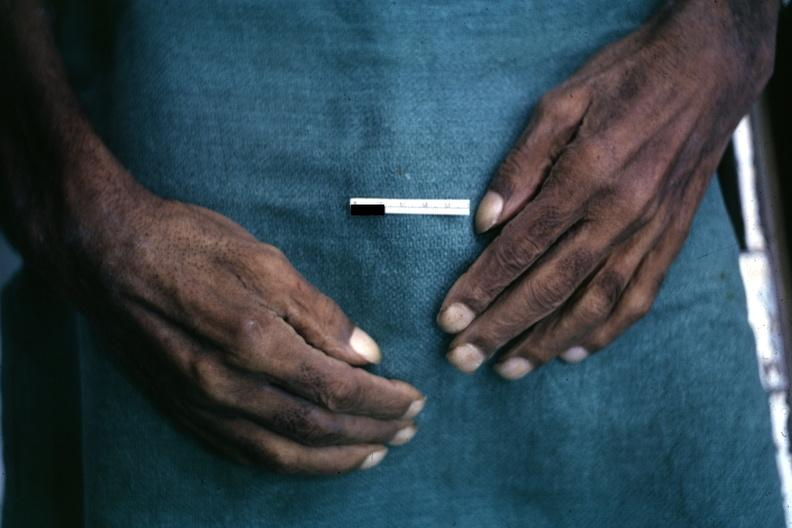what are present?
Answer the question using a single word or phrase. Extremities 